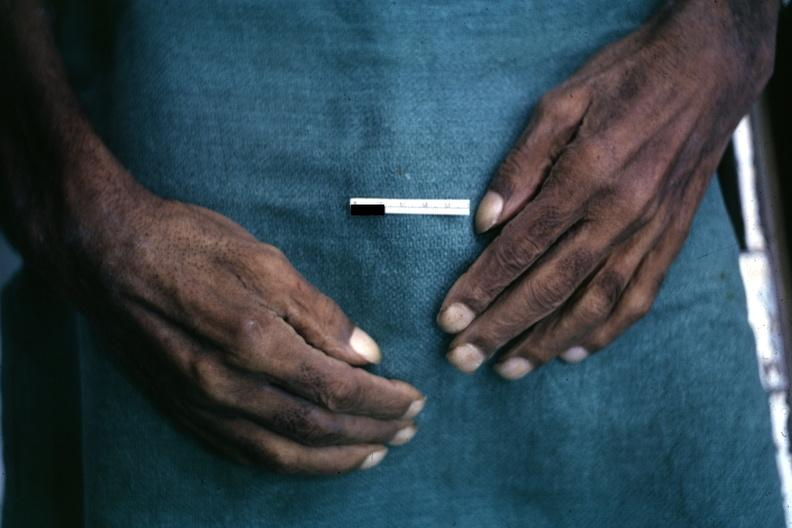what are present?
Answer the question using a single word or phrase. Extremities 